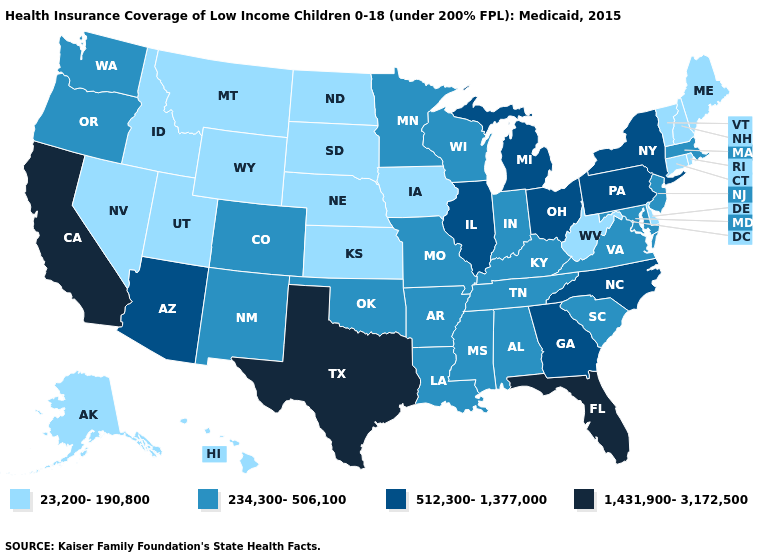Name the states that have a value in the range 23,200-190,800?
Answer briefly. Alaska, Connecticut, Delaware, Hawaii, Idaho, Iowa, Kansas, Maine, Montana, Nebraska, Nevada, New Hampshire, North Dakota, Rhode Island, South Dakota, Utah, Vermont, West Virginia, Wyoming. Which states hav the highest value in the Northeast?
Write a very short answer. New York, Pennsylvania. Does Maine have the lowest value in the Northeast?
Quick response, please. Yes. Among the states that border Oregon , which have the highest value?
Quick response, please. California. What is the value of Maryland?
Keep it brief. 234,300-506,100. Name the states that have a value in the range 1,431,900-3,172,500?
Be succinct. California, Florida, Texas. What is the highest value in the USA?
Keep it brief. 1,431,900-3,172,500. Among the states that border Virginia , which have the highest value?
Be succinct. North Carolina. What is the highest value in the USA?
Give a very brief answer. 1,431,900-3,172,500. What is the value of North Dakota?
Quick response, please. 23,200-190,800. What is the value of Wyoming?
Write a very short answer. 23,200-190,800. Does Florida have the highest value in the USA?
Quick response, please. Yes. Name the states that have a value in the range 1,431,900-3,172,500?
Give a very brief answer. California, Florida, Texas. How many symbols are there in the legend?
Short answer required. 4. Which states hav the highest value in the South?
Concise answer only. Florida, Texas. 